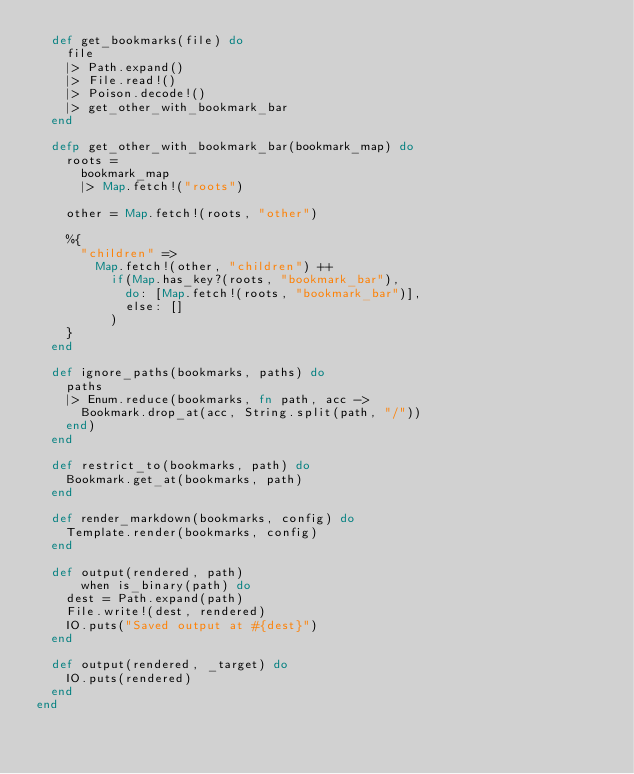Convert code to text. <code><loc_0><loc_0><loc_500><loc_500><_Elixir_>  def get_bookmarks(file) do
    file
    |> Path.expand()
    |> File.read!()
    |> Poison.decode!()
    |> get_other_with_bookmark_bar
  end

  defp get_other_with_bookmark_bar(bookmark_map) do
    roots =
      bookmark_map
      |> Map.fetch!("roots")

    other = Map.fetch!(roots, "other")

    %{
      "children" =>
        Map.fetch!(other, "children") ++
          if(Map.has_key?(roots, "bookmark_bar"),
            do: [Map.fetch!(roots, "bookmark_bar")],
            else: []
          )
    }
  end

  def ignore_paths(bookmarks, paths) do
    paths
    |> Enum.reduce(bookmarks, fn path, acc ->
      Bookmark.drop_at(acc, String.split(path, "/"))
    end)
  end

  def restrict_to(bookmarks, path) do
    Bookmark.get_at(bookmarks, path)
  end

  def render_markdown(bookmarks, config) do
    Template.render(bookmarks, config)
  end

  def output(rendered, path)
      when is_binary(path) do
    dest = Path.expand(path)
    File.write!(dest, rendered)
    IO.puts("Saved output at #{dest}")
  end

  def output(rendered, _target) do
    IO.puts(rendered)
  end
end
</code> 